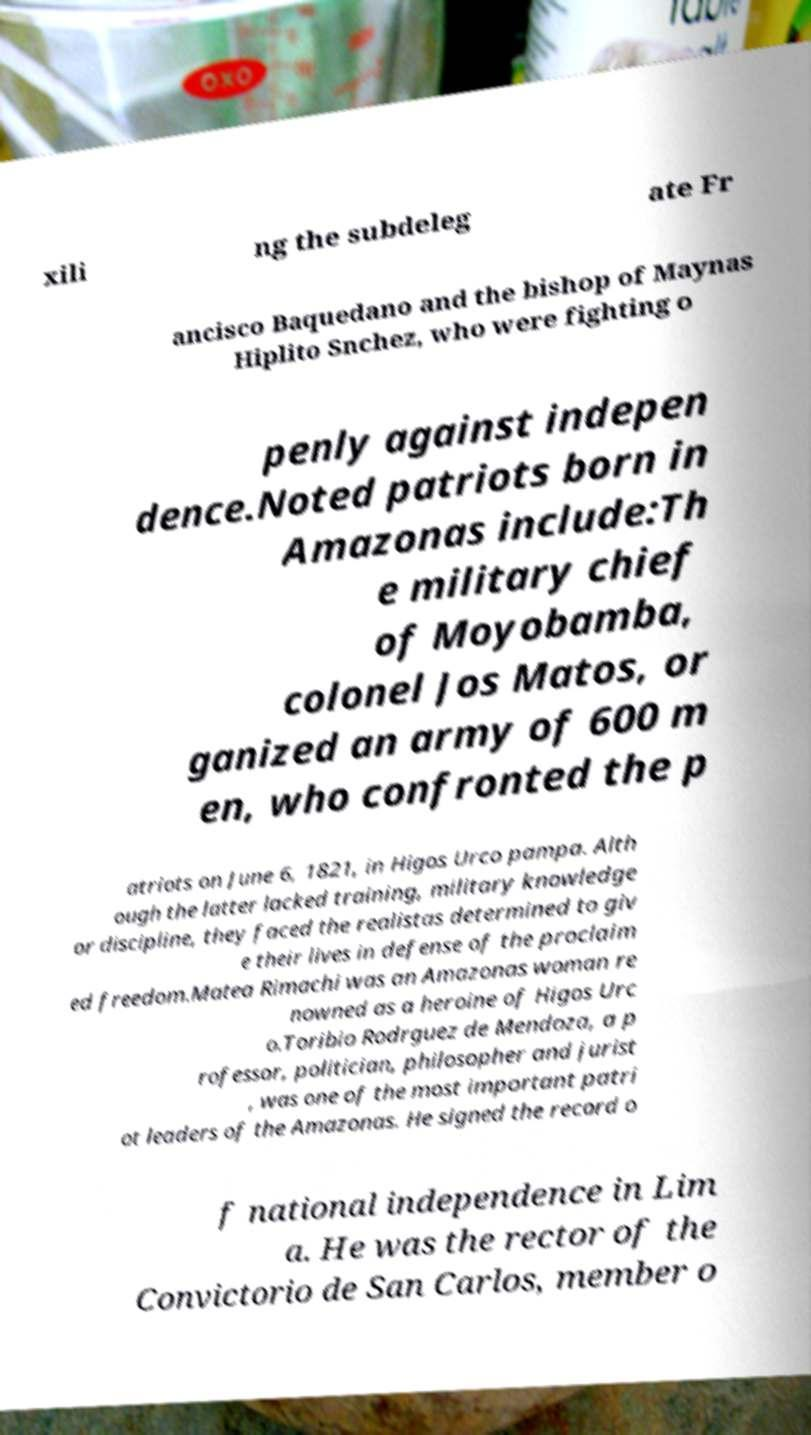I need the written content from this picture converted into text. Can you do that? xili ng the subdeleg ate Fr ancisco Baquedano and the bishop of Maynas Hiplito Snchez, who were fighting o penly against indepen dence.Noted patriots born in Amazonas include:Th e military chief of Moyobamba, colonel Jos Matos, or ganized an army of 600 m en, who confronted the p atriots on June 6, 1821, in Higos Urco pampa. Alth ough the latter lacked training, military knowledge or discipline, they faced the realistas determined to giv e their lives in defense of the proclaim ed freedom.Matea Rimachi was an Amazonas woman re nowned as a heroine of Higos Urc o.Toribio Rodrguez de Mendoza, a p rofessor, politician, philosopher and jurist , was one of the most important patri ot leaders of the Amazonas. He signed the record o f national independence in Lim a. He was the rector of the Convictorio de San Carlos, member o 